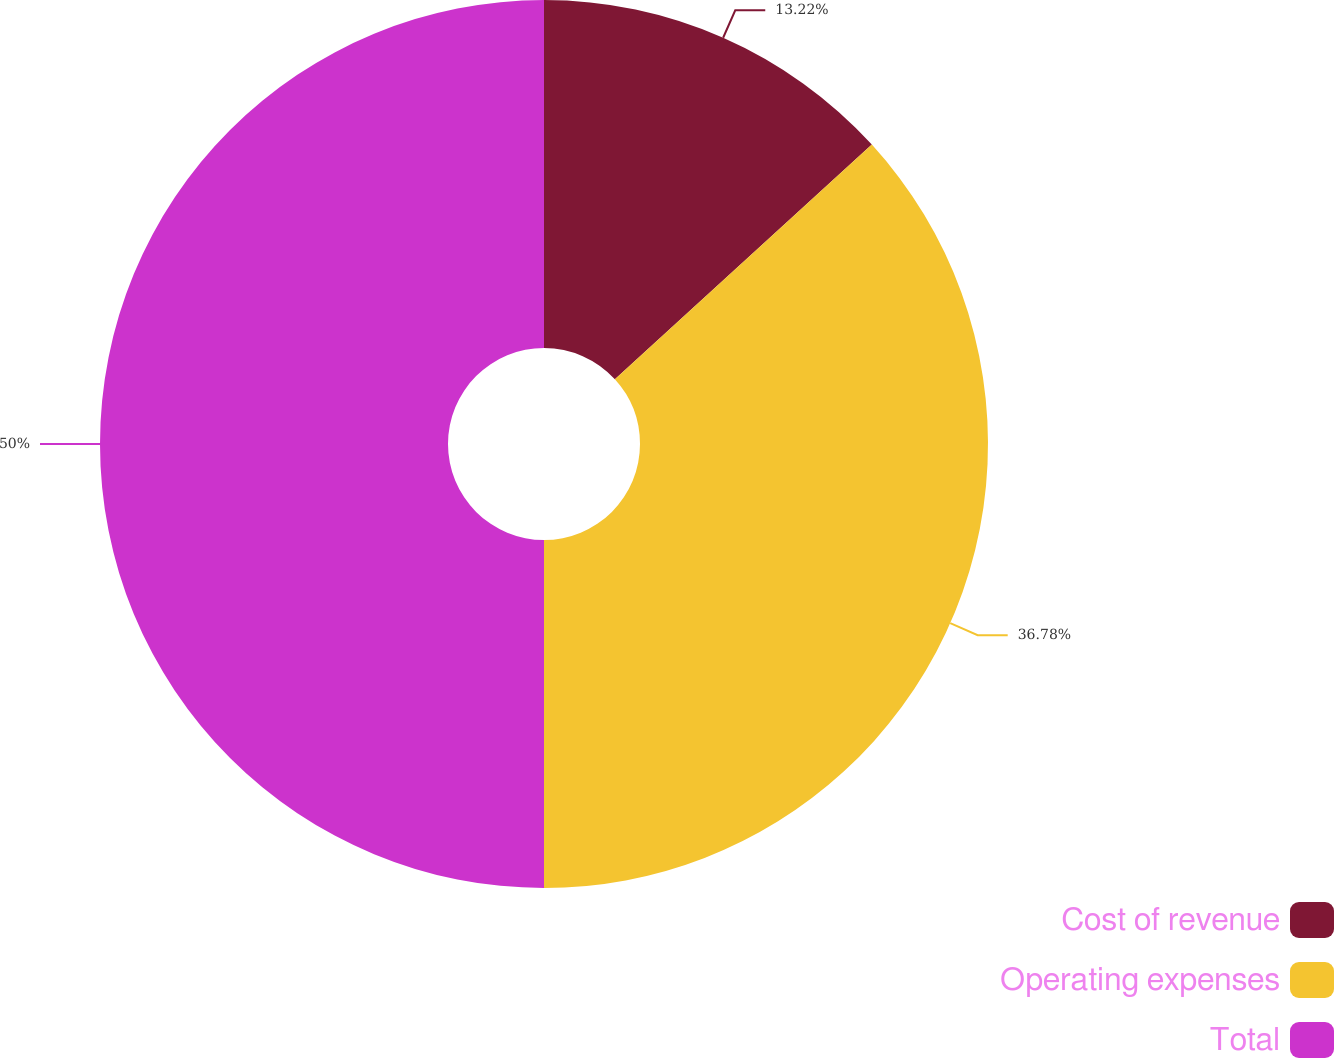Convert chart. <chart><loc_0><loc_0><loc_500><loc_500><pie_chart><fcel>Cost of revenue<fcel>Operating expenses<fcel>Total<nl><fcel>13.22%<fcel>36.78%<fcel>50.0%<nl></chart> 